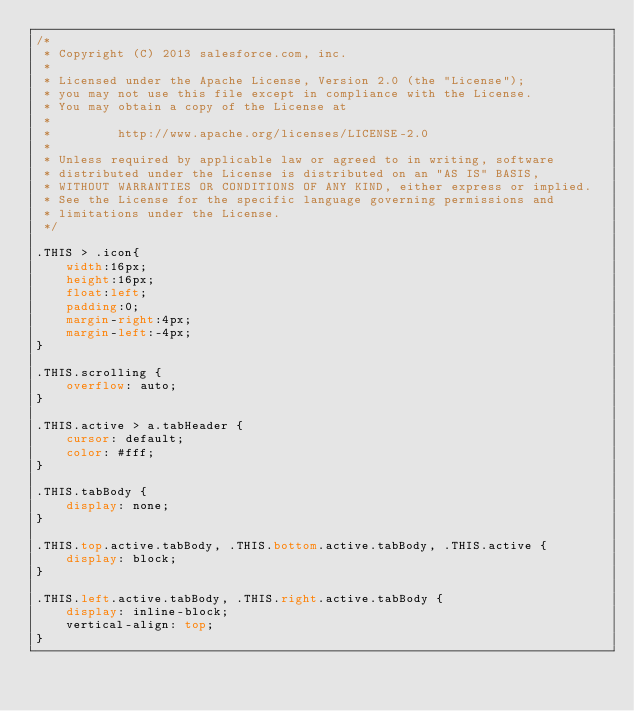Convert code to text. <code><loc_0><loc_0><loc_500><loc_500><_CSS_>/*
 * Copyright (C) 2013 salesforce.com, inc.
 *
 * Licensed under the Apache License, Version 2.0 (the "License");
 * you may not use this file except in compliance with the License.
 * You may obtain a copy of the License at
 *
 *         http://www.apache.org/licenses/LICENSE-2.0
 *
 * Unless required by applicable law or agreed to in writing, software
 * distributed under the License is distributed on an "AS IS" BASIS,
 * WITHOUT WARRANTIES OR CONDITIONS OF ANY KIND, either express or implied.
 * See the License for the specific language governing permissions and
 * limitations under the License.
 */

.THIS > .icon{
	width:16px;
	height:16px;
	float:left;
	padding:0;
	margin-right:4px;
	margin-left:-4px;
}

.THIS.scrolling {
	overflow: auto;
}

.THIS.active > a.tabHeader {
	cursor: default;
	color: #fff;
}

.THIS.tabBody {	
	display: none;
}

.THIS.top.active.tabBody, .THIS.bottom.active.tabBody, .THIS.active {
	display: block;
}

.THIS.left.active.tabBody, .THIS.right.active.tabBody {
    display: inline-block;
    vertical-align: top;
}
</code> 